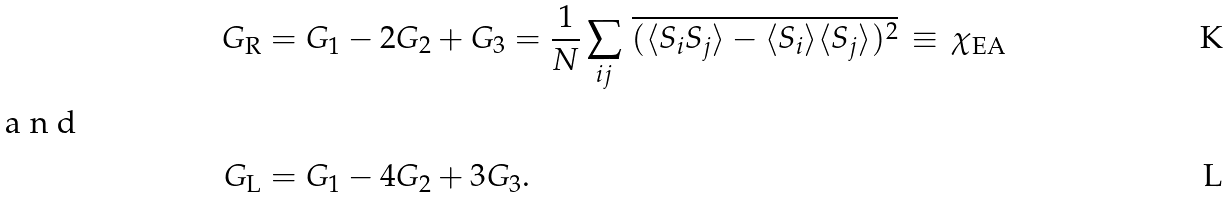Convert formula to latex. <formula><loc_0><loc_0><loc_500><loc_500>G _ { \text {R} } & = G _ { 1 } - 2 G _ { 2 } + G _ { 3 } = \frac { 1 } { N } \sum _ { i j } \, \overline { ( \langle S _ { i } S _ { j } \rangle - \langle S _ { i } \rangle \langle S _ { j } \rangle ) ^ { 2 } } \, \equiv \, \chi _ { \text {EA} } \\ \intertext { a n d } G _ { \text {L} } & = G _ { 1 } - 4 G _ { 2 } + 3 G _ { 3 } .</formula> 